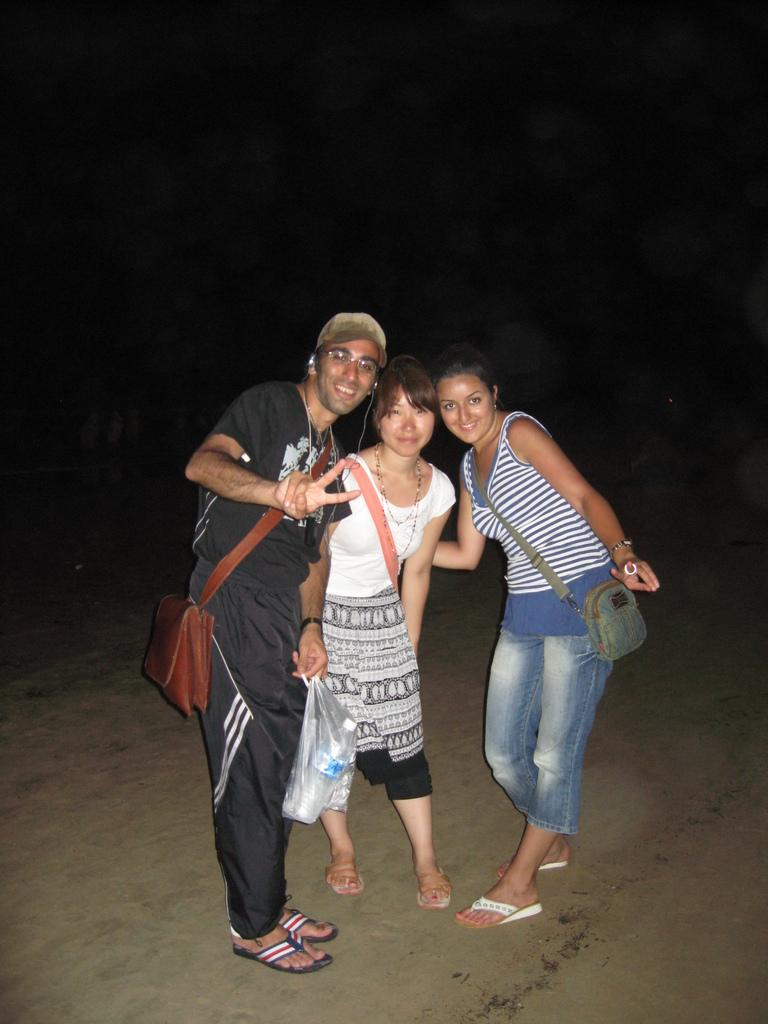How many people are in the image? There are three persons in the image. What are the people in the image doing? The three persons are standing. What expressions do the people have? The persons are smiling. What is the left side person holding? The left side person is holding a plastic cover. Can you see any volcanoes in the image? There are no volcanoes present in the image. Are the people in the image spying on someone? There is no indication in the image that the people are spying on anyone. 